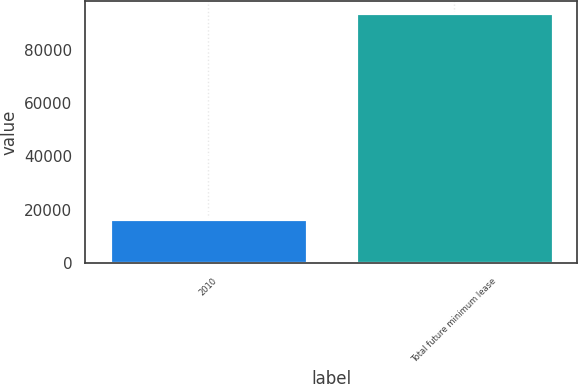<chart> <loc_0><loc_0><loc_500><loc_500><bar_chart><fcel>2010<fcel>Total future minimum lease<nl><fcel>16579<fcel>93504<nl></chart> 